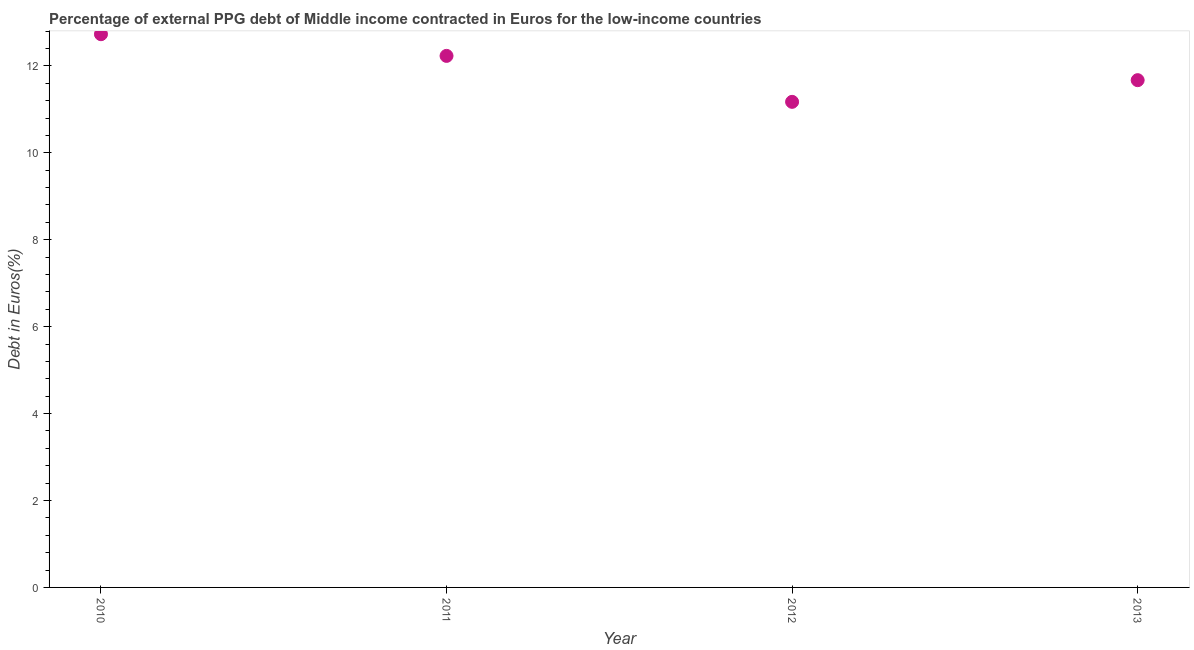What is the currency composition of ppg debt in 2011?
Your answer should be very brief. 12.23. Across all years, what is the maximum currency composition of ppg debt?
Ensure brevity in your answer.  12.73. Across all years, what is the minimum currency composition of ppg debt?
Your answer should be compact. 11.17. In which year was the currency composition of ppg debt maximum?
Make the answer very short. 2010. In which year was the currency composition of ppg debt minimum?
Your response must be concise. 2012. What is the sum of the currency composition of ppg debt?
Give a very brief answer. 47.81. What is the difference between the currency composition of ppg debt in 2012 and 2013?
Make the answer very short. -0.5. What is the average currency composition of ppg debt per year?
Provide a succinct answer. 11.95. What is the median currency composition of ppg debt?
Your answer should be very brief. 11.95. In how many years, is the currency composition of ppg debt greater than 6.4 %?
Ensure brevity in your answer.  4. What is the ratio of the currency composition of ppg debt in 2010 to that in 2011?
Keep it short and to the point. 1.04. Is the currency composition of ppg debt in 2010 less than that in 2013?
Ensure brevity in your answer.  No. What is the difference between the highest and the second highest currency composition of ppg debt?
Keep it short and to the point. 0.5. Is the sum of the currency composition of ppg debt in 2010 and 2013 greater than the maximum currency composition of ppg debt across all years?
Your answer should be very brief. Yes. What is the difference between the highest and the lowest currency composition of ppg debt?
Provide a succinct answer. 1.56. Does the currency composition of ppg debt monotonically increase over the years?
Provide a short and direct response. No. How many dotlines are there?
Offer a terse response. 1. How many years are there in the graph?
Give a very brief answer. 4. What is the difference between two consecutive major ticks on the Y-axis?
Provide a short and direct response. 2. Are the values on the major ticks of Y-axis written in scientific E-notation?
Your answer should be very brief. No. Does the graph contain grids?
Give a very brief answer. No. What is the title of the graph?
Ensure brevity in your answer.  Percentage of external PPG debt of Middle income contracted in Euros for the low-income countries. What is the label or title of the X-axis?
Provide a short and direct response. Year. What is the label or title of the Y-axis?
Your response must be concise. Debt in Euros(%). What is the Debt in Euros(%) in 2010?
Provide a succinct answer. 12.73. What is the Debt in Euros(%) in 2011?
Make the answer very short. 12.23. What is the Debt in Euros(%) in 2012?
Provide a short and direct response. 11.17. What is the Debt in Euros(%) in 2013?
Keep it short and to the point. 11.67. What is the difference between the Debt in Euros(%) in 2010 and 2011?
Your response must be concise. 0.5. What is the difference between the Debt in Euros(%) in 2010 and 2012?
Keep it short and to the point. 1.56. What is the difference between the Debt in Euros(%) in 2010 and 2013?
Keep it short and to the point. 1.06. What is the difference between the Debt in Euros(%) in 2011 and 2012?
Your response must be concise. 1.06. What is the difference between the Debt in Euros(%) in 2011 and 2013?
Provide a short and direct response. 0.56. What is the difference between the Debt in Euros(%) in 2012 and 2013?
Make the answer very short. -0.5. What is the ratio of the Debt in Euros(%) in 2010 to that in 2011?
Provide a short and direct response. 1.04. What is the ratio of the Debt in Euros(%) in 2010 to that in 2012?
Make the answer very short. 1.14. What is the ratio of the Debt in Euros(%) in 2010 to that in 2013?
Your answer should be very brief. 1.09. What is the ratio of the Debt in Euros(%) in 2011 to that in 2012?
Ensure brevity in your answer.  1.09. What is the ratio of the Debt in Euros(%) in 2011 to that in 2013?
Provide a short and direct response. 1.05. What is the ratio of the Debt in Euros(%) in 2012 to that in 2013?
Your answer should be very brief. 0.96. 